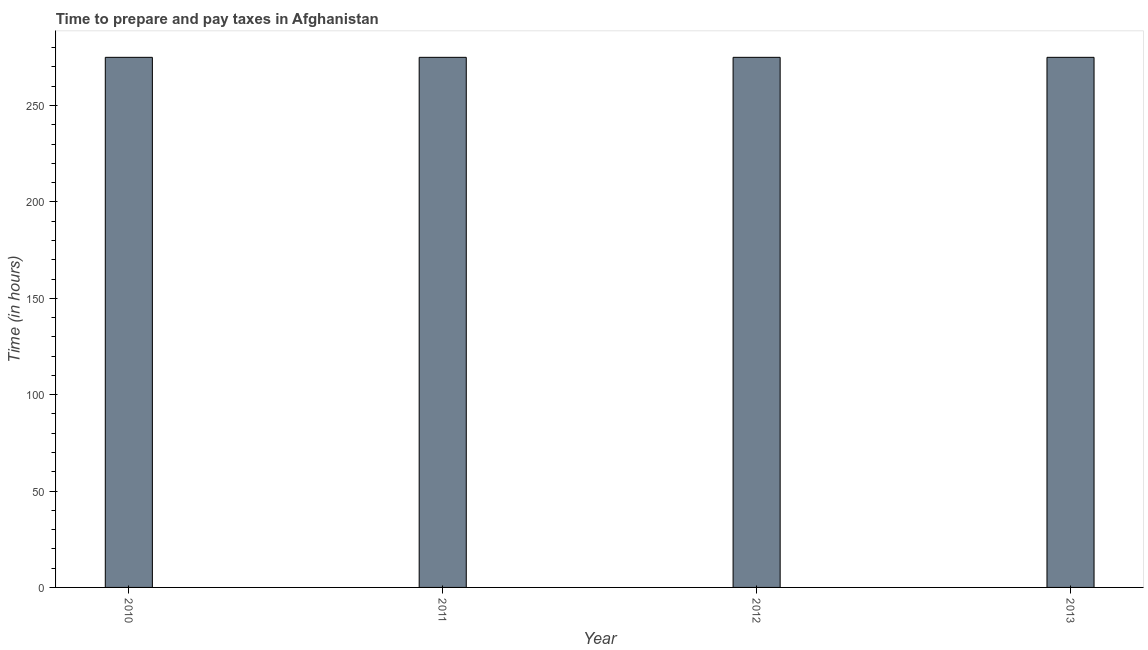What is the title of the graph?
Ensure brevity in your answer.  Time to prepare and pay taxes in Afghanistan. What is the label or title of the X-axis?
Make the answer very short. Year. What is the label or title of the Y-axis?
Keep it short and to the point. Time (in hours). What is the time to prepare and pay taxes in 2011?
Your response must be concise. 275. Across all years, what is the maximum time to prepare and pay taxes?
Offer a terse response. 275. Across all years, what is the minimum time to prepare and pay taxes?
Offer a terse response. 275. What is the sum of the time to prepare and pay taxes?
Keep it short and to the point. 1100. What is the average time to prepare and pay taxes per year?
Provide a succinct answer. 275. What is the median time to prepare and pay taxes?
Your response must be concise. 275. In how many years, is the time to prepare and pay taxes greater than 80 hours?
Ensure brevity in your answer.  4. What is the ratio of the time to prepare and pay taxes in 2010 to that in 2012?
Offer a very short reply. 1. What is the difference between the highest and the lowest time to prepare and pay taxes?
Provide a short and direct response. 0. Are all the bars in the graph horizontal?
Keep it short and to the point. No. What is the difference between two consecutive major ticks on the Y-axis?
Offer a terse response. 50. Are the values on the major ticks of Y-axis written in scientific E-notation?
Offer a terse response. No. What is the Time (in hours) of 2010?
Give a very brief answer. 275. What is the Time (in hours) of 2011?
Provide a succinct answer. 275. What is the Time (in hours) in 2012?
Provide a short and direct response. 275. What is the Time (in hours) of 2013?
Provide a succinct answer. 275. What is the difference between the Time (in hours) in 2010 and 2012?
Keep it short and to the point. 0. What is the difference between the Time (in hours) in 2011 and 2012?
Your response must be concise. 0. What is the difference between the Time (in hours) in 2011 and 2013?
Give a very brief answer. 0. What is the ratio of the Time (in hours) in 2010 to that in 2012?
Ensure brevity in your answer.  1. What is the ratio of the Time (in hours) in 2010 to that in 2013?
Provide a succinct answer. 1. 